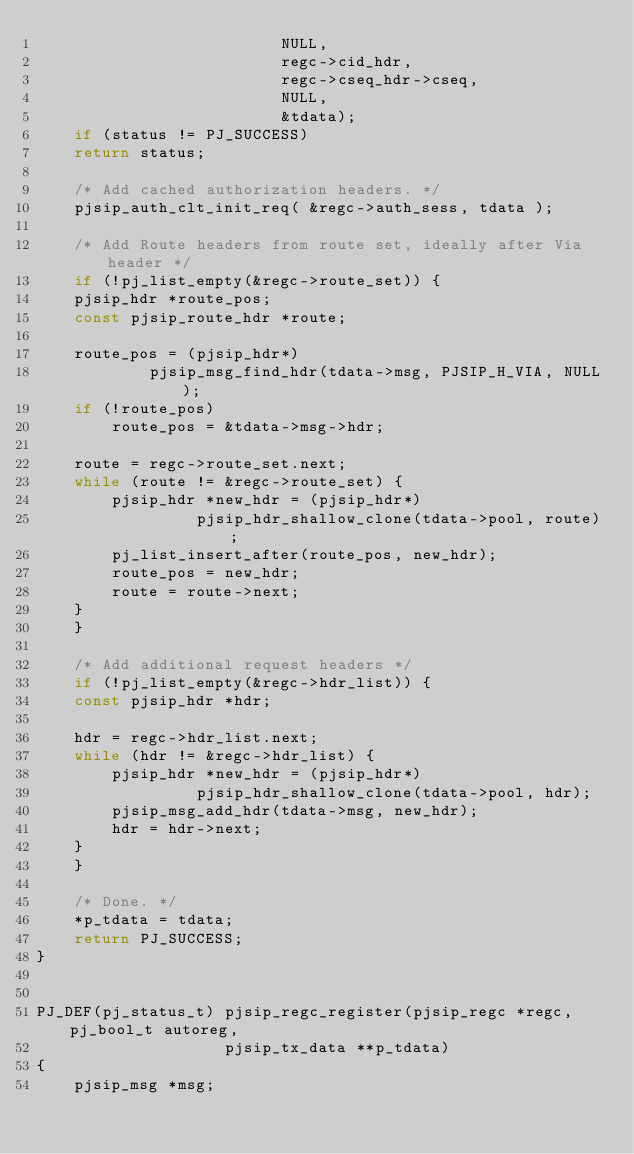<code> <loc_0><loc_0><loc_500><loc_500><_C_>						  NULL,
						  regc->cid_hdr,
						  regc->cseq_hdr->cseq,
						  NULL,
						  &tdata);
    if (status != PJ_SUCCESS)
	return status;

    /* Add cached authorization headers. */
    pjsip_auth_clt_init_req( &regc->auth_sess, tdata );

    /* Add Route headers from route set, ideally after Via header */
    if (!pj_list_empty(&regc->route_set)) {
	pjsip_hdr *route_pos;
	const pjsip_route_hdr *route;

	route_pos = (pjsip_hdr*)
		    pjsip_msg_find_hdr(tdata->msg, PJSIP_H_VIA, NULL);
	if (!route_pos)
	    route_pos = &tdata->msg->hdr;

	route = regc->route_set.next;
	while (route != &regc->route_set) {
	    pjsip_hdr *new_hdr = (pjsip_hdr*)
				 pjsip_hdr_shallow_clone(tdata->pool, route);
	    pj_list_insert_after(route_pos, new_hdr);
	    route_pos = new_hdr;
	    route = route->next;
	}
    }

    /* Add additional request headers */
    if (!pj_list_empty(&regc->hdr_list)) {
	const pjsip_hdr *hdr;

	hdr = regc->hdr_list.next;
	while (hdr != &regc->hdr_list) {
	    pjsip_hdr *new_hdr = (pjsip_hdr*)
				 pjsip_hdr_shallow_clone(tdata->pool, hdr);
	    pjsip_msg_add_hdr(tdata->msg, new_hdr);
	    hdr = hdr->next;
	}
    }

    /* Done. */
    *p_tdata = tdata;
    return PJ_SUCCESS;
}


PJ_DEF(pj_status_t) pjsip_regc_register(pjsip_regc *regc, pj_bool_t autoreg,
					pjsip_tx_data **p_tdata)
{
    pjsip_msg *msg;</code> 